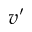<formula> <loc_0><loc_0><loc_500><loc_500>v ^ { \prime }</formula> 